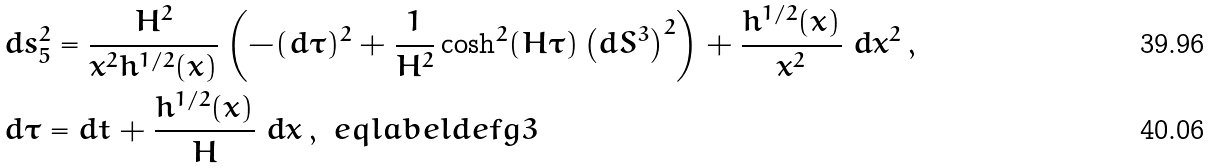Convert formula to latex. <formula><loc_0><loc_0><loc_500><loc_500>& d s _ { 5 } ^ { 2 } = \frac { H ^ { 2 } } { x ^ { 2 } h ^ { 1 / 2 } ( x ) } \left ( - ( d \tau ) ^ { 2 } + \frac { 1 } { H ^ { 2 } } \cosh ^ { 2 } ( H \tau ) \left ( d S ^ { 3 } \right ) ^ { 2 } \right ) + \frac { h ^ { 1 / 2 } ( x ) } { x ^ { 2 } } \ d x ^ { 2 } \, , \\ & d \tau = d t + \frac { h ^ { 1 / 2 } ( x ) } { H } \ d x \, , \ e q l a b e l { d e f g 3 }</formula> 